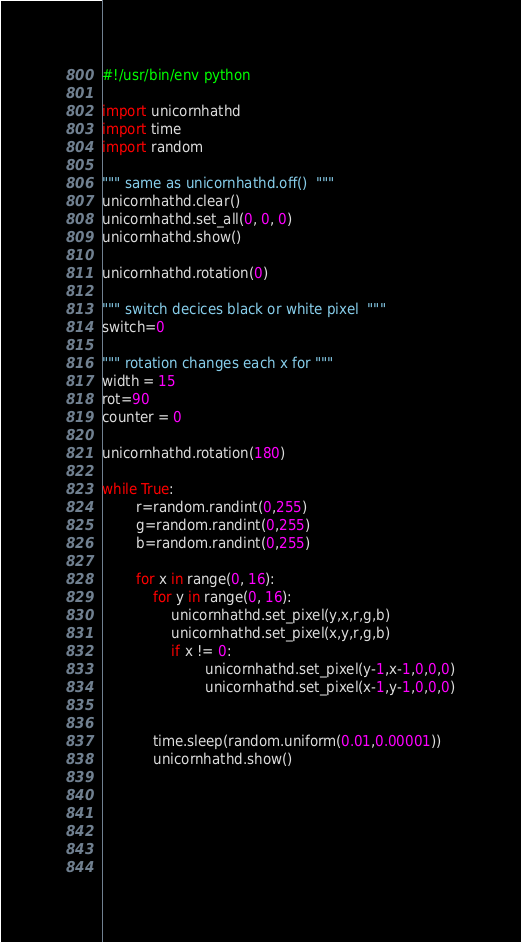<code> <loc_0><loc_0><loc_500><loc_500><_Python_>#!/usr/bin/env python

import unicornhathd
import time
import random

""" same as unicornhathd.off()  """
unicornhathd.clear()
unicornhathd.set_all(0, 0, 0)
unicornhathd.show()

unicornhathd.rotation(0)

""" switch decices black or white pixel  """ 
switch=0

""" rotation changes each x for """
width = 15
rot=90
counter = 0

unicornhathd.rotation(180)

while True:
        r=random.randint(0,255)
        g=random.randint(0,255)
        b=random.randint(0,255)
        
        for x in range(0, 16):
            for y in range(0, 16):
                unicornhathd.set_pixel(y,x,r,g,b)
                unicornhathd.set_pixel(x,y,r,g,b)
                if x != 0:
                        unicornhathd.set_pixel(y-1,x-1,0,0,0)
                        unicornhathd.set_pixel(x-1,y-1,0,0,0)

                    
            time.sleep(random.uniform(0.01,0.00001))
            unicornhathd.show()
                
        
                


                
</code> 